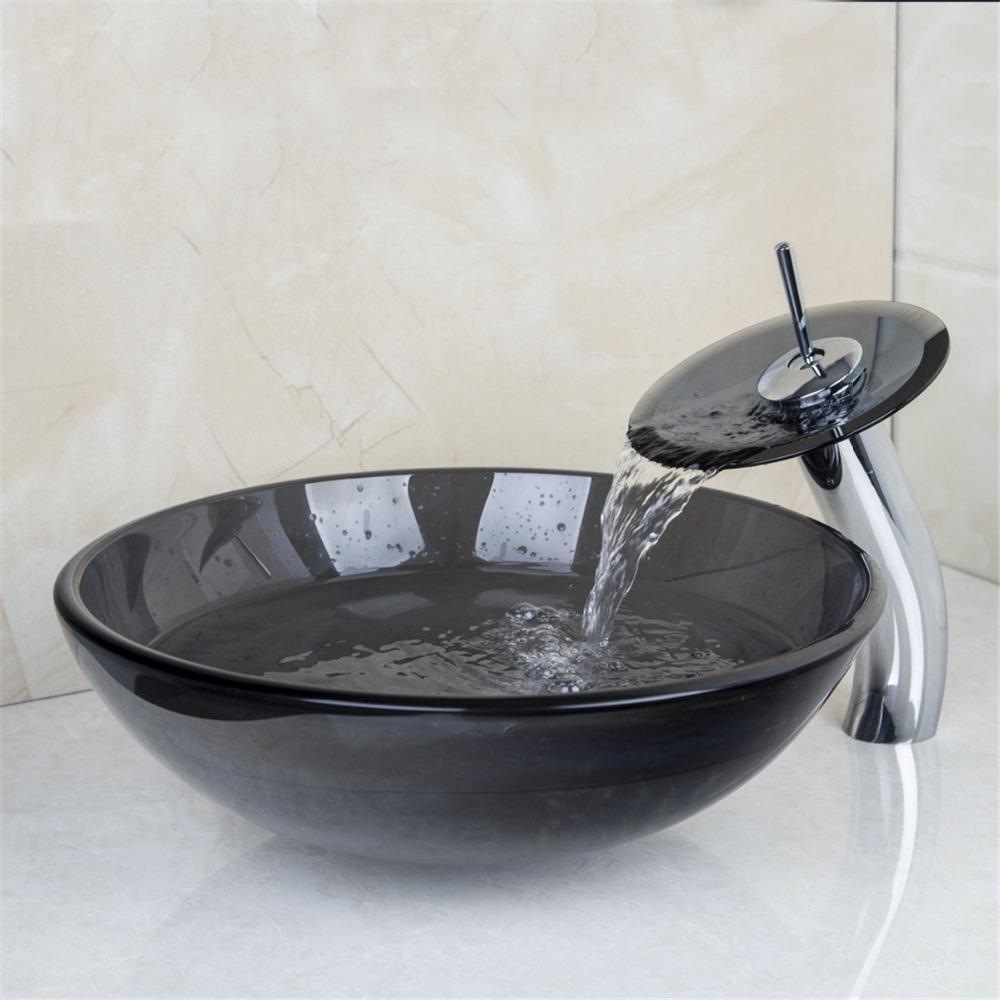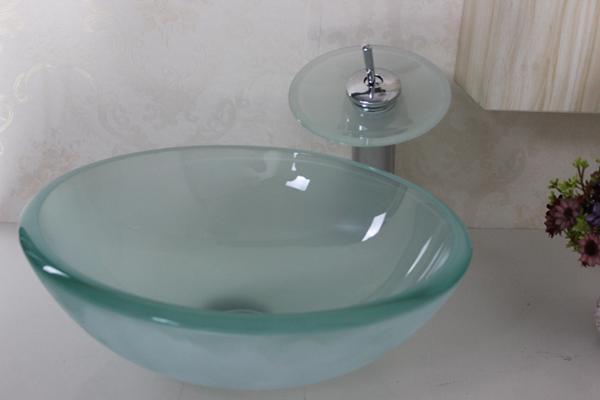The first image is the image on the left, the second image is the image on the right. Given the left and right images, does the statement "The bowl in each pair is the same color" hold true? Answer yes or no. No. The first image is the image on the left, the second image is the image on the right. Given the left and right images, does the statement "At least one image contains a transparent wash basin." hold true? Answer yes or no. Yes. 